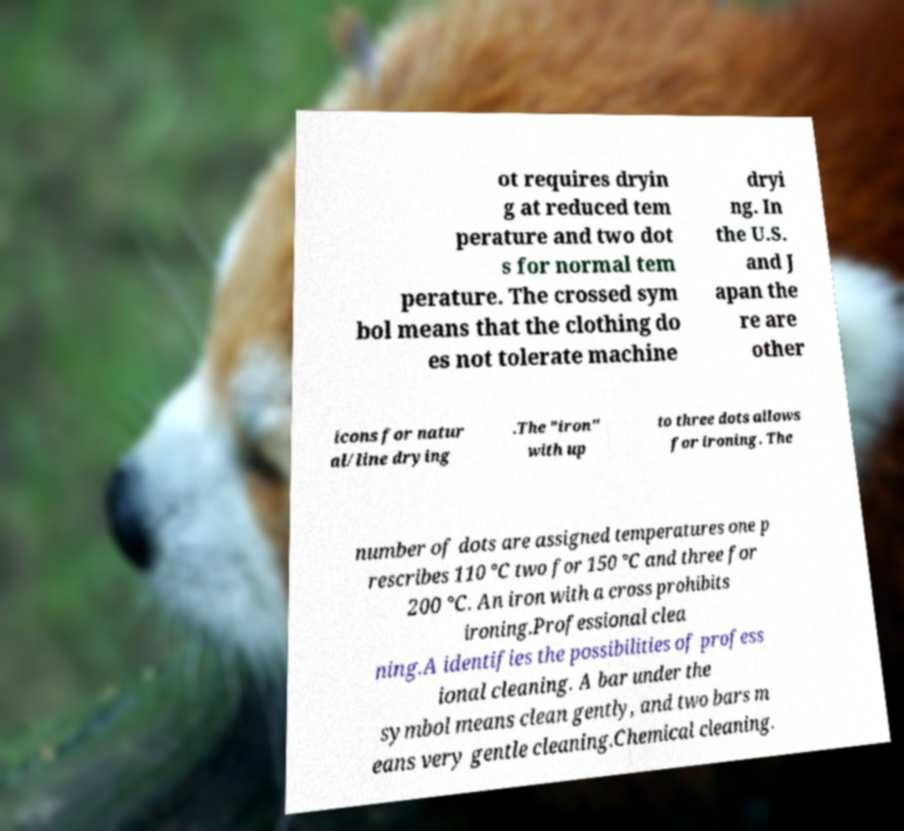Could you extract and type out the text from this image? ot requires dryin g at reduced tem perature and two dot s for normal tem perature. The crossed sym bol means that the clothing do es not tolerate machine dryi ng. In the U.S. and J apan the re are other icons for natur al/line drying .The "iron" with up to three dots allows for ironing. The number of dots are assigned temperatures one p rescribes 110 °C two for 150 °C and three for 200 °C. An iron with a cross prohibits ironing.Professional clea ning.A identifies the possibilities of profess ional cleaning. A bar under the symbol means clean gently, and two bars m eans very gentle cleaning.Chemical cleaning. 